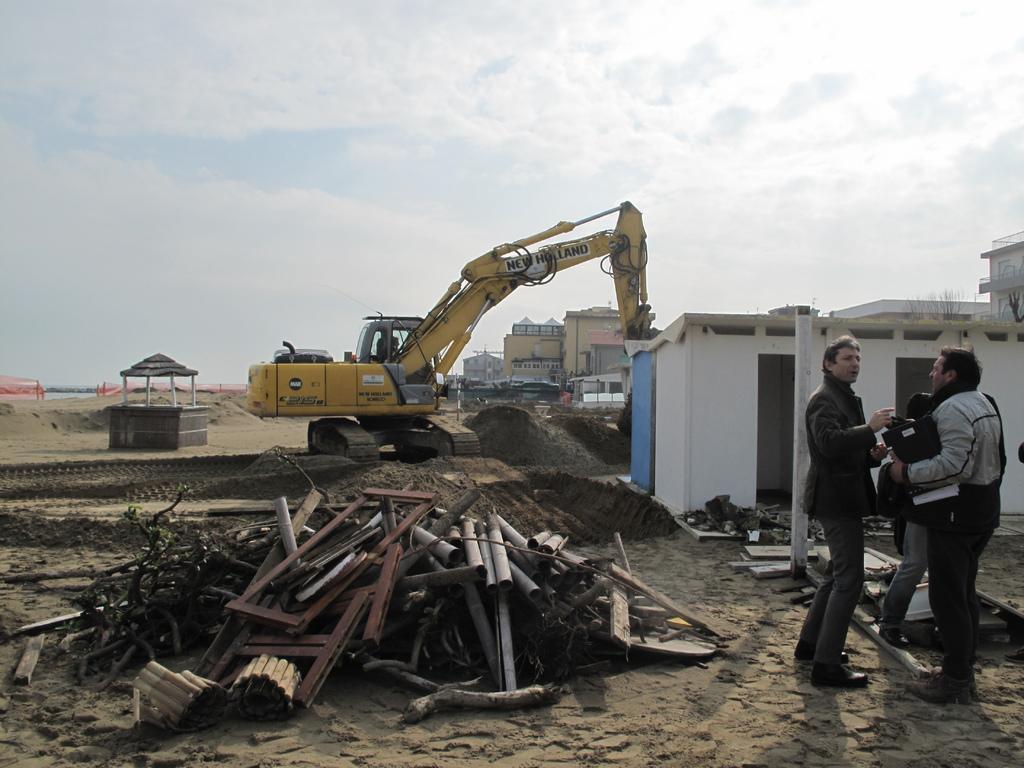Could you give a brief overview of what you see in this image? This picture is clicked outside. On the right we can see the group of persons standing on the ground and we can see there are many number of objects lying on the ground and we can see the crane, buildings, mud and some other objects. In the background we can see the sky. 